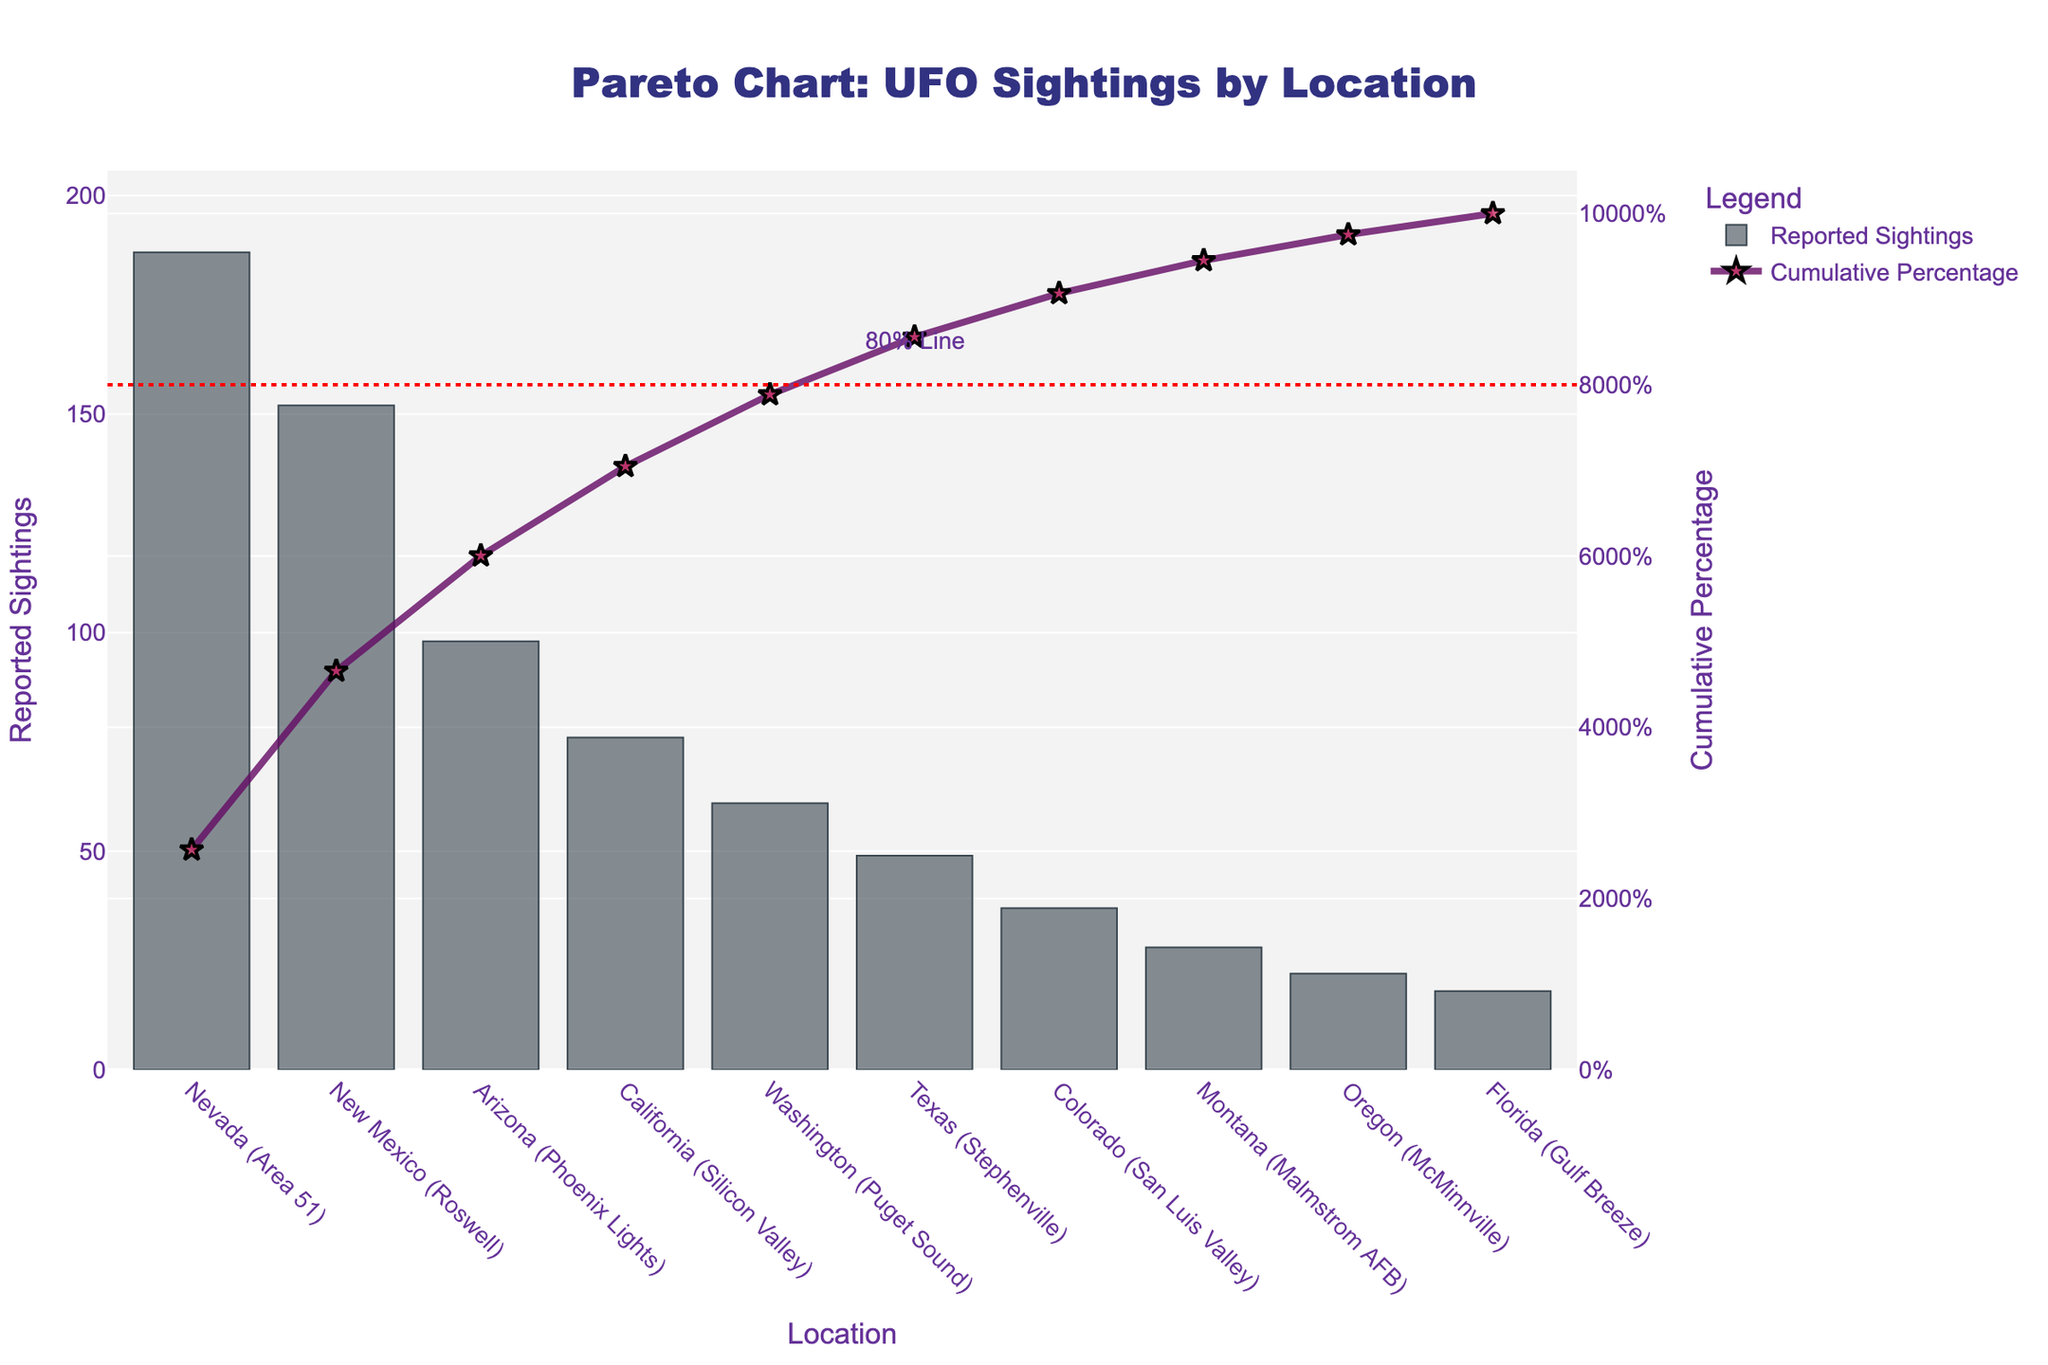what is the title of the figure? The title is typically located at the top of the figure, centrally aligned. The text is "Pareto Chart: UFO Sightings by Location," referring to the chart’s purpose and content.
Answer: Pareto Chart: UFO Sightings by Location How many locations have reported sightings? Each bar on the x-axis represents a unique location. Counting them gives the total number of locations.
Answer: 10 Which location has the highest number of reported sightings? The bar with the greatest height indicates the location with the highest number of reported sightings. Nevada (Area 51) is the highest.
Answer: Nevada (Area 51) What does the red dotted line represent, and where is it positioned? The red dotted line is positioned at 80% on the right y-axis, indicating the cumulative percentage at which it cuts off. Its position is annotated with "80% Line."
Answer: 80% what is the cumulative percentage of reported sightings up to Arizona (Phoenix Lights)? Locate Arizona (Phoenix Lights) on the x-axis, then follow the corresponding point on the cumulative percentage line to read the value from the right y-axis.
Answer: Approximately 70% Which location marks the point where the cumulative percentage first exceeds 50%? Observe the cumulative percentage line and identify the location where it first surpasses the 50% mark on the right y-axis.
Answer: New Mexico (Roswell) How does the number of sightings in Texas (Stephenville) compare to those in Florida (Gulf Breeze)? Compare the heights of the bars representing Texas (Stephenville) and Florida (Gulf Breeze) on the left y-axis. Texas has 49 sightings, and Florida has 18 sightings. Texas has more sightings.
Answer: Texas (Stephenville) has more What percentage of total sightings do the top three locations account for? Calculate the cumulative percentage at the third location (Arizona) on the x-axis by looking at the cumulative percentage line on the right y-axis.
Answer: Approximately 85% Which location has the fewest reported sightings, and how many are there? The shortest bar represents the location with the fewest sightings. Florida (Gulf Breeze) has the smallest bar.
Answer: Florida (Gulf Breeze), 18 identify the locations where the cumulative percentage shows significant increases. Look for the steepest segments of the cumulative percentage line where large increases take place between locations.
Answer: From Nevada (Area 51) to New Mexico (Roswell) to Arizona (Phoenix Lights) 